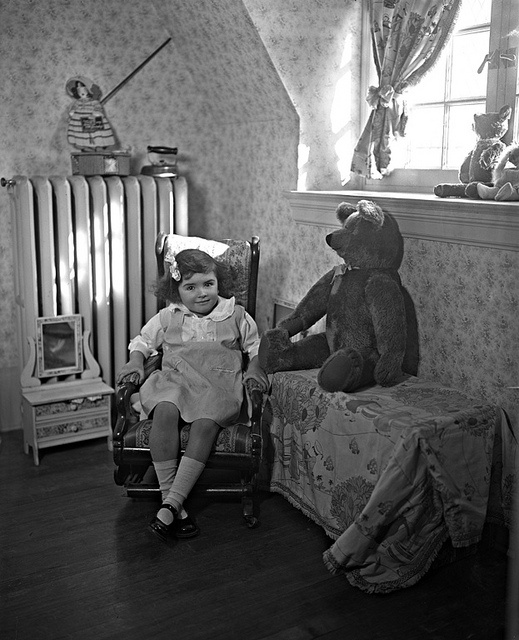Describe the objects in this image and their specific colors. I can see people in gray, darkgray, black, and lightgray tones, teddy bear in gray, black, darkgray, and lightgray tones, chair in gray, black, and lightgray tones, and teddy bear in gray, darkgray, lightgray, and black tones in this image. 